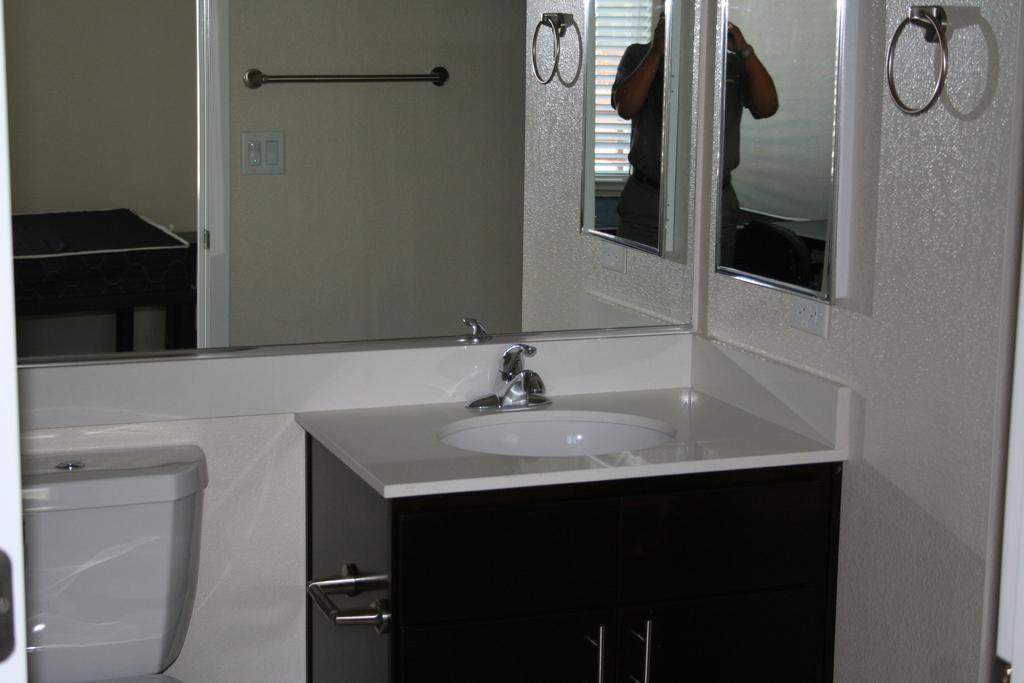Please provide a concise description of this image. In this picture we can see a bathroom vanity. On the left side of the bathroom vanity, there is a flush tank. Behind the flush tank there is a mirror and on the mirror we can see the reflection of another mirror, a person, handle, an object and the walls. 